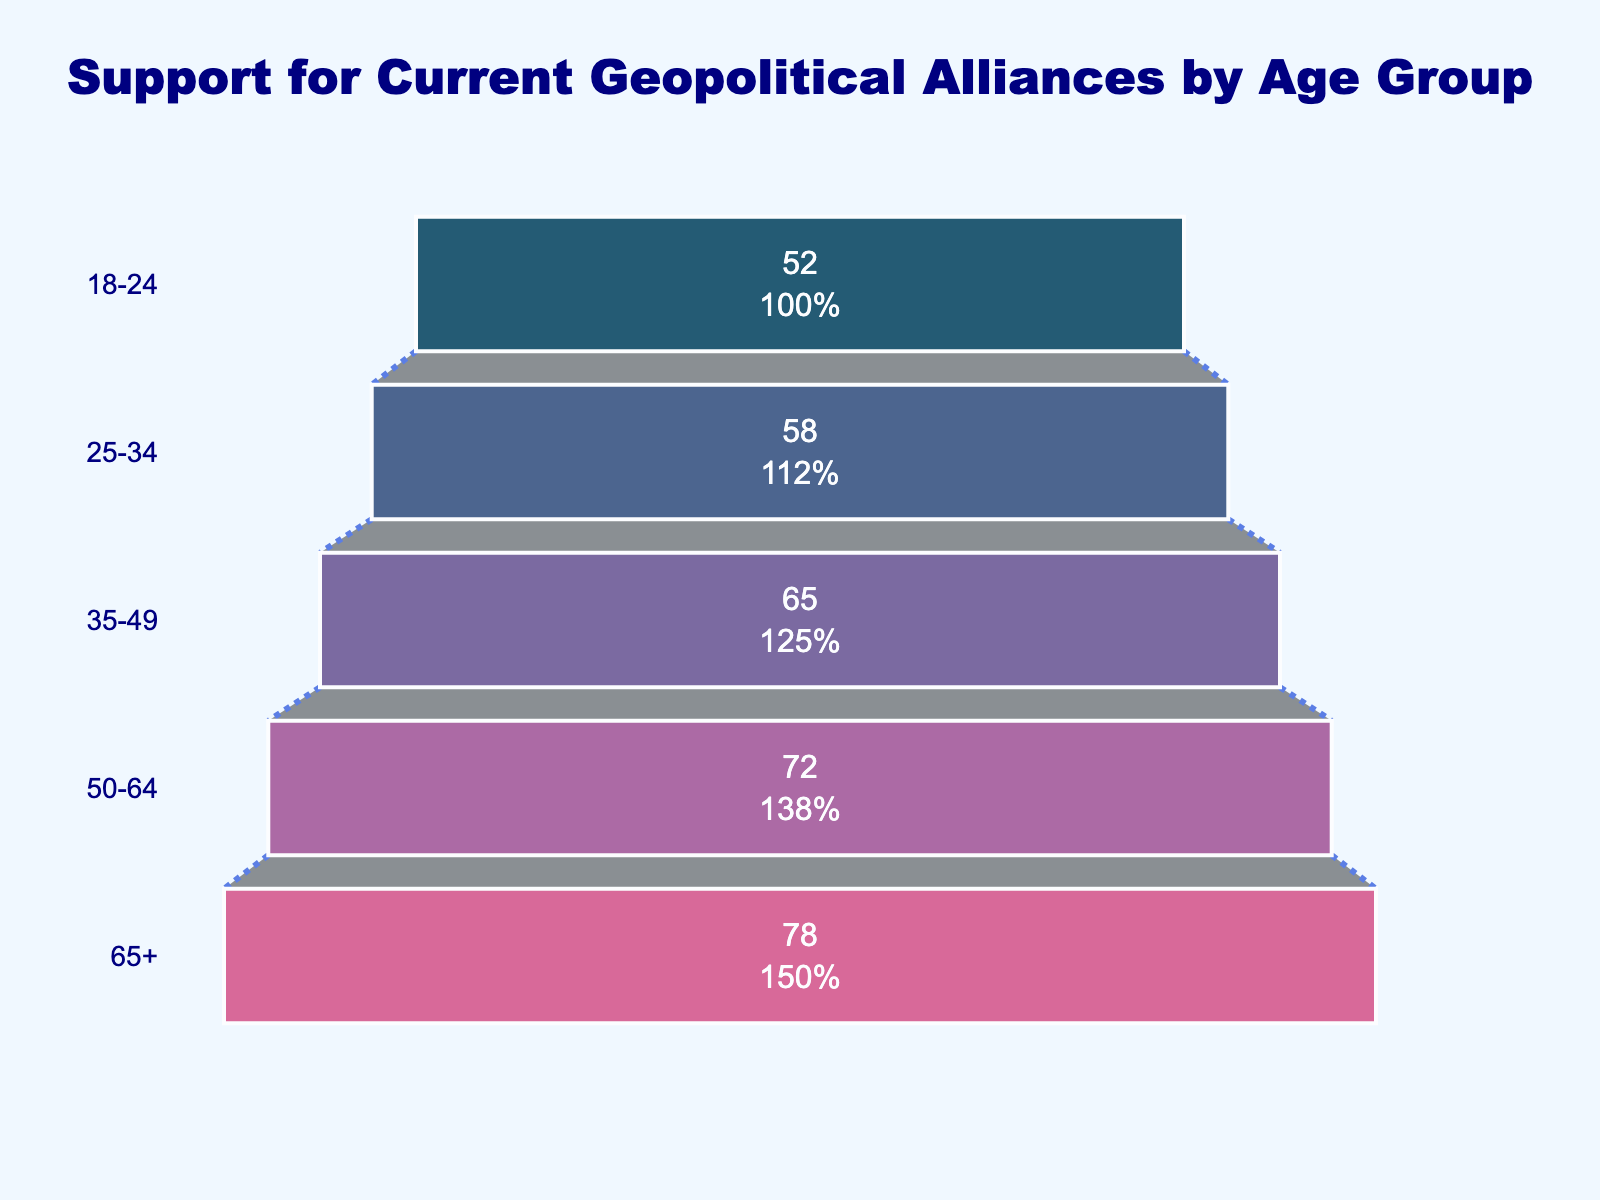What is the title of the funnel chart? The title is displayed at the top center of the chart in large, bold font. By reading the title directly from the figure, we see it mentions the subject of the data.
Answer: Support for Current Geopolitical Alliances by Age Group What is the general trend in support for current geopolitical alliances as age increases? Observing the support percentages from the bottom to the top of the funnel, we can see that support increases with age, with younger age groups showing lower support percentages and older age groups showing higher support percentages.
Answer: Support increases with age Which age group has the highest support for current geopolitical alliances? Looking at the top-most section of the funnel, we see the age group with the highest percentage support. The figure indicates that the 65+ age group has the highest support at 78%.
Answer: 65+ Which age group has the lowest support for current geopolitical alliances? Glancing at the bottom-most section of the funnel shows the age group with the lowest percentage support. The figure shows it is the 18-24 age group with 52%.
Answer: 18-24 By how much does the support for current geopolitical alliances in the 35-49 age group differ from the 25-34 age group? We subtract the support percentage of the 25-34 age group from that of the 35-49 age group: 65% - 58% = 7%.
Answer: 7% What is the average support percentage for maintaining current geopolitical alliances across all age groups? To find the average, sum the support percentages of all age groups and divide by the number of age groups: (78 + 72 + 65 + 58 + 52) / 5 = 65%.
Answer: 65% How do the support percentages of the 50-64 age group and the 35-49 age group compare? From the chart, the 50-64 age group has 72% support, and the 35-49 age group has 65% support. A simple comparison shows that the 50-64 age group has a higher support percentage.
Answer: 50-64 > 35-49 Can you identify the color scheme used for the different segments of the funnel chart? Observing the colors visually, the chart segments range from dark blue at the top to lighter shades of purple and red as we go down the funnel: "#003f5c", "#2f4b7c", "#665191", "#a05195", "#d45087".
Answer: Dark blue to lighter shades of purple and red What is the sum of the support percentages for the age groups 18-24 and 25-34? Add the support percentages for these age groups: 52% + 58% = 110%.
Answer: 110% Which age group shows a closer percentage of support to the overall average support for all age groups? First, determine the average support percentage, which is 65%. Then, compare this value to each age group's support. The 35-49 age group's support percentage of 65% matches the average exactly.
Answer: 35-49 